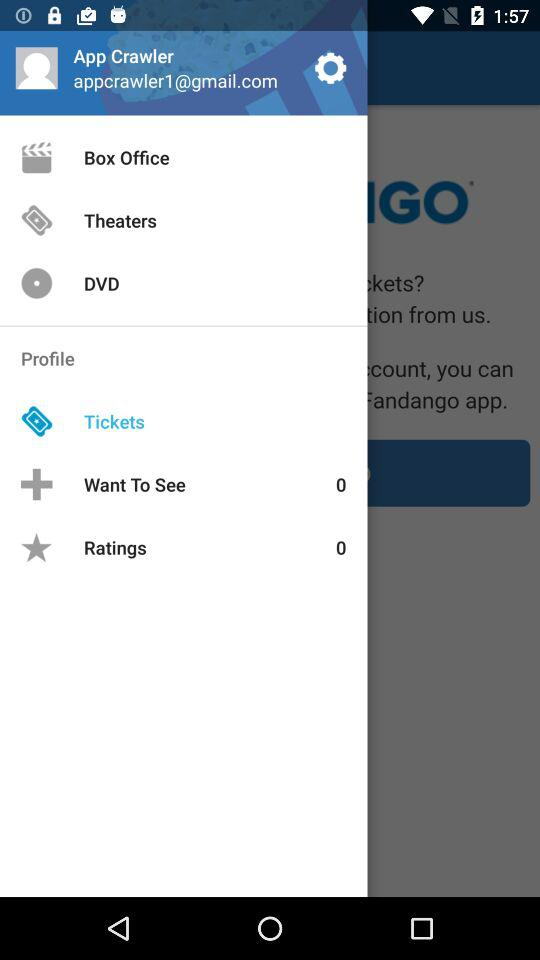What's the Gmail address? The Gmail address is appcrawler1@gmail.com. 